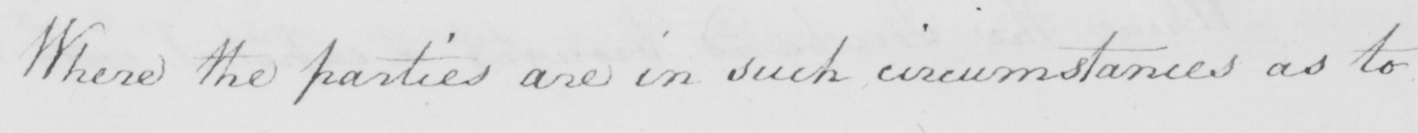Can you read and transcribe this handwriting? Where the parties are in such circumstances as to 